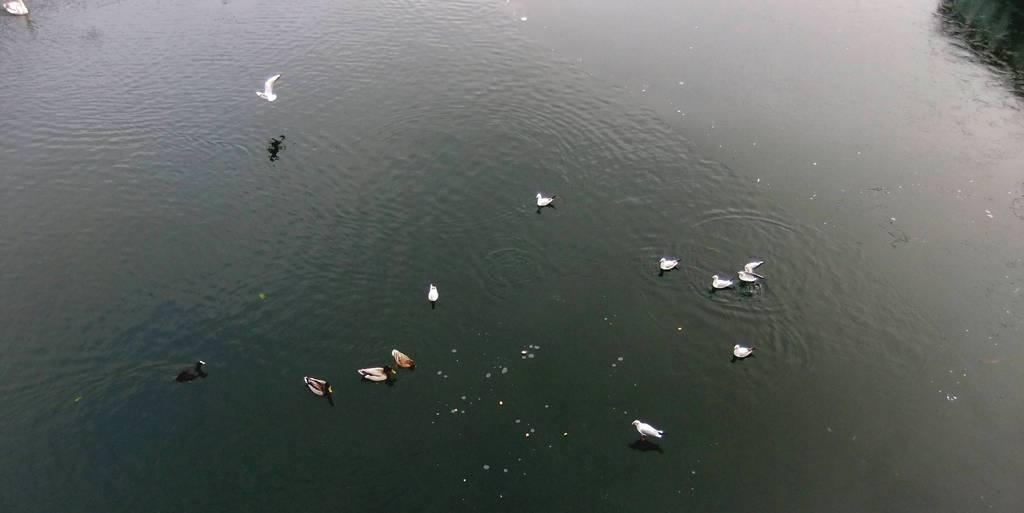What type of animals are in the water in the image? There are ducks in the water in the image. What is happening in the sky in the image? A bird is flying in the image. What advice does the father give to the donkey in the image? There is no father or donkey present in the image; it features ducks in the water and a flying bird. 